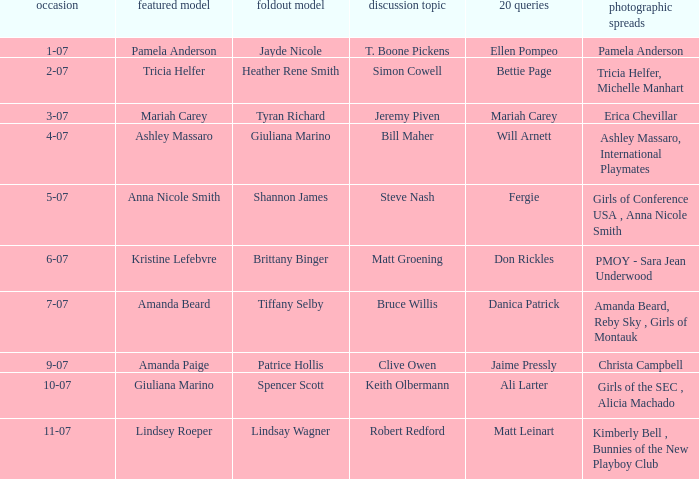Parse the table in full. {'header': ['occasion', 'featured model', 'foldout model', 'discussion topic', '20 queries', 'photographic spreads'], 'rows': [['1-07', 'Pamela Anderson', 'Jayde Nicole', 'T. Boone Pickens', 'Ellen Pompeo', 'Pamela Anderson'], ['2-07', 'Tricia Helfer', 'Heather Rene Smith', 'Simon Cowell', 'Bettie Page', 'Tricia Helfer, Michelle Manhart'], ['3-07', 'Mariah Carey', 'Tyran Richard', 'Jeremy Piven', 'Mariah Carey', 'Erica Chevillar'], ['4-07', 'Ashley Massaro', 'Giuliana Marino', 'Bill Maher', 'Will Arnett', 'Ashley Massaro, International Playmates'], ['5-07', 'Anna Nicole Smith', 'Shannon James', 'Steve Nash', 'Fergie', 'Girls of Conference USA , Anna Nicole Smith'], ['6-07', 'Kristine Lefebvre', 'Brittany Binger', 'Matt Groening', 'Don Rickles', 'PMOY - Sara Jean Underwood'], ['7-07', 'Amanda Beard', 'Tiffany Selby', 'Bruce Willis', 'Danica Patrick', 'Amanda Beard, Reby Sky , Girls of Montauk'], ['9-07', 'Amanda Paige', 'Patrice Hollis', 'Clive Owen', 'Jaime Pressly', 'Christa Campbell'], ['10-07', 'Giuliana Marino', 'Spencer Scott', 'Keith Olbermann', 'Ali Larter', 'Girls of the SEC , Alicia Machado'], ['11-07', 'Lindsey Roeper', 'Lindsay Wagner', 'Robert Redford', 'Matt Leinart', 'Kimberly Bell , Bunnies of the New Playboy Club']]} Who was the centerfold model when the issue's pictorial was kimberly bell , bunnies of the new playboy club? Lindsay Wagner. 